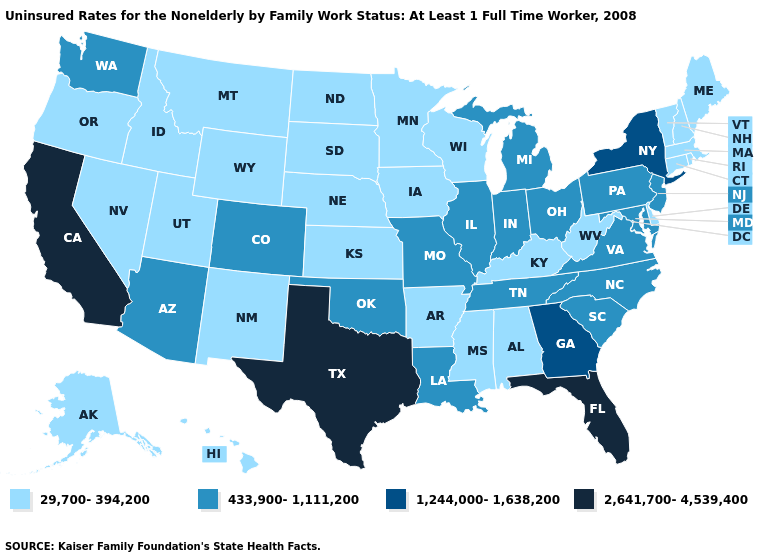Among the states that border New Hampshire , which have the lowest value?
Write a very short answer. Maine, Massachusetts, Vermont. What is the value of Idaho?
Concise answer only. 29,700-394,200. Does the first symbol in the legend represent the smallest category?
Concise answer only. Yes. What is the value of Wyoming?
Write a very short answer. 29,700-394,200. What is the value of Wisconsin?
Write a very short answer. 29,700-394,200. Is the legend a continuous bar?
Write a very short answer. No. What is the highest value in the USA?
Answer briefly. 2,641,700-4,539,400. What is the value of Alabama?
Keep it brief. 29,700-394,200. Name the states that have a value in the range 2,641,700-4,539,400?
Answer briefly. California, Florida, Texas. What is the lowest value in the Northeast?
Keep it brief. 29,700-394,200. Name the states that have a value in the range 1,244,000-1,638,200?
Write a very short answer. Georgia, New York. What is the value of Oregon?
Quick response, please. 29,700-394,200. Which states have the highest value in the USA?
Concise answer only. California, Florida, Texas. Does the first symbol in the legend represent the smallest category?
Be succinct. Yes. 